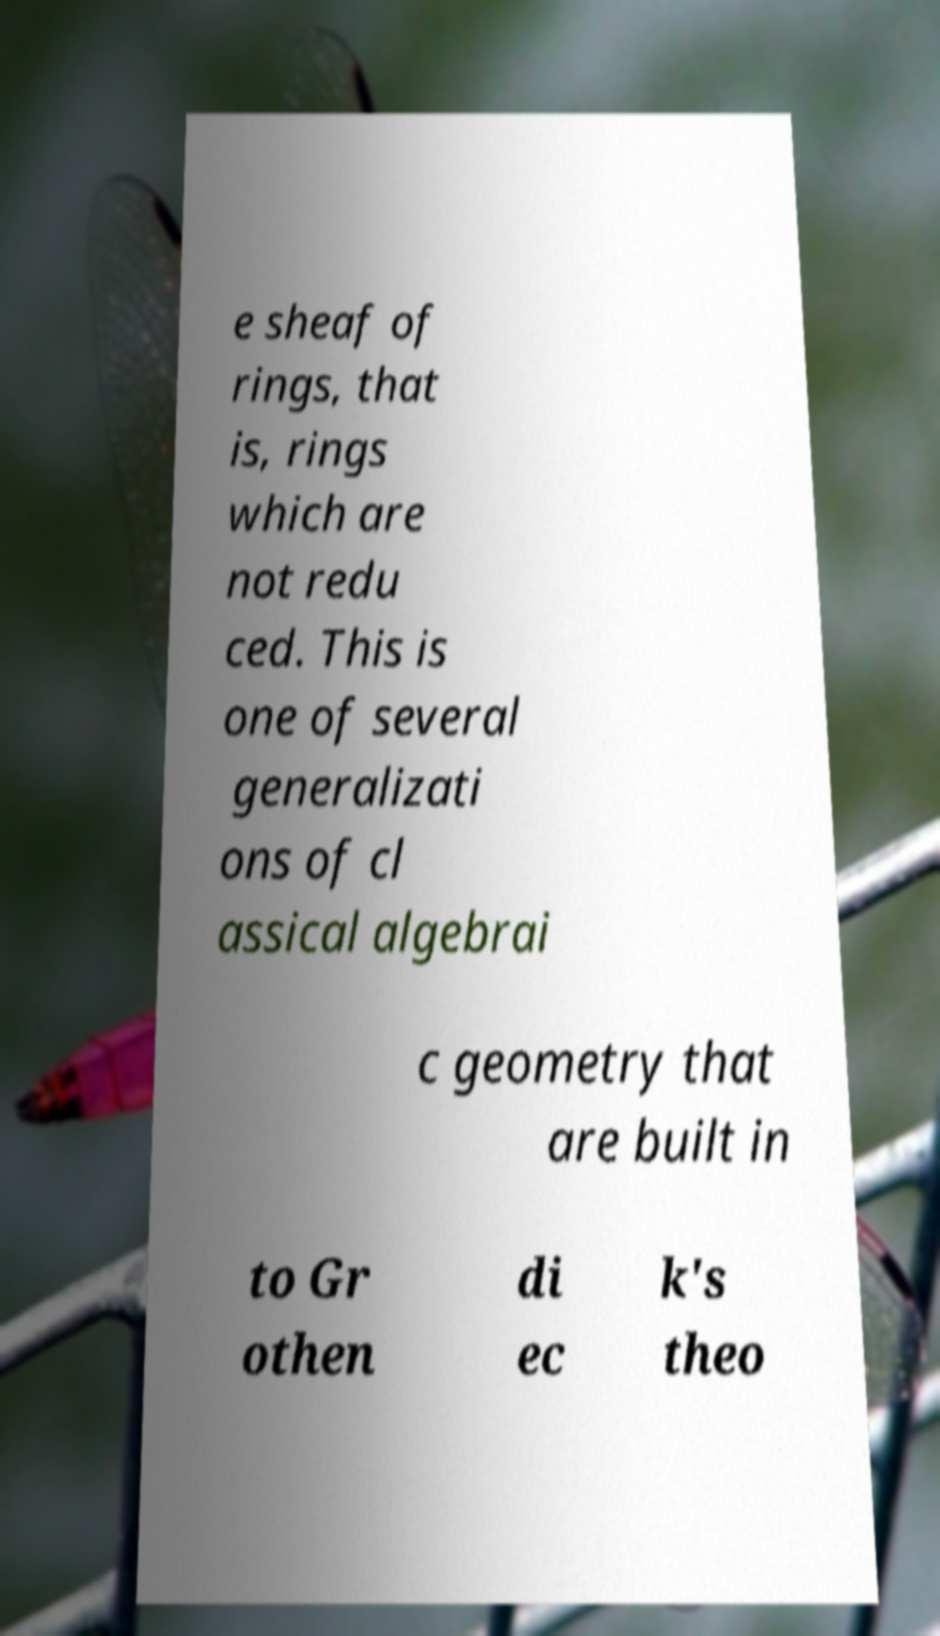I need the written content from this picture converted into text. Can you do that? e sheaf of rings, that is, rings which are not redu ced. This is one of several generalizati ons of cl assical algebrai c geometry that are built in to Gr othen di ec k's theo 